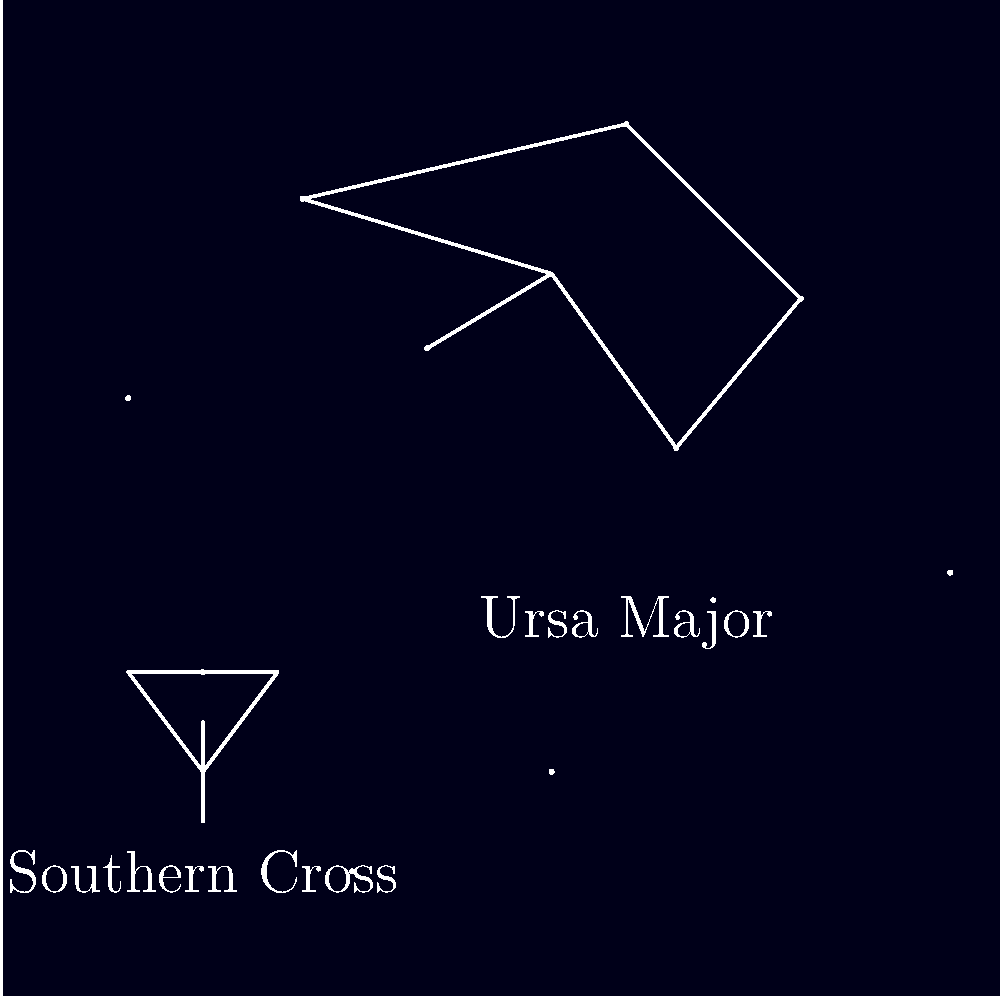Which of these constellations is typically visible in the night sky over Vietnam throughout the year, and why is the other one not consistently visible? To answer this question, we need to consider Vietnam's geographical location and how it affects the visibility of constellations:

1. Vietnam's location: Vietnam is in Southeast Asia, lying between approximately 8°N and 23°N latitude.

2. Ursa Major (The Great Bear):
   - Ursa Major is a northern constellation.
   - It is circumpolar (always above the horizon) for observers north of 41°N latitude.
   - For Vietnam's latitude, Ursa Major is visible for most of the year, especially in the northern parts of the country.
   - It may dip below the horizon briefly in the southernmost parts of Vietnam during certain times of the year.

3. Southern Cross (Crux):
   - The Southern Cross is a southern constellation.
   - It is circumpolar (always above the horizon) for observers south of 34°S latitude.
   - Vietnam is too far north to see the Southern Cross consistently.
   - The Southern Cross may be visible very low on the horizon in the southernmost parts of Vietnam during certain times of the year, but it's not a reliable sight.

4. Conclusion: Ursa Major is typically visible in the night sky over Vietnam throughout the year, while the Southern Cross is not consistently visible due to Vietnam's northern hemisphere location.
Answer: Ursa Major; Vietnam's northern hemisphere location 